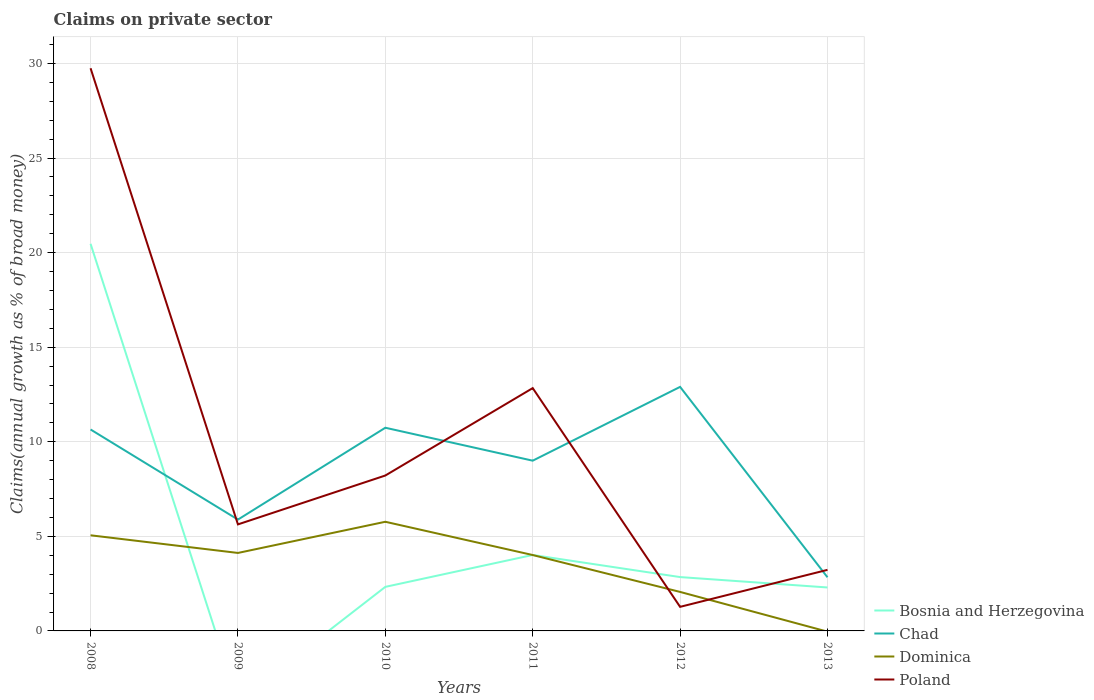How many different coloured lines are there?
Your response must be concise. 4. Does the line corresponding to Poland intersect with the line corresponding to Dominica?
Ensure brevity in your answer.  Yes. Is the number of lines equal to the number of legend labels?
Offer a very short reply. No. Across all years, what is the maximum percentage of broad money claimed on private sector in Dominica?
Keep it short and to the point. 0. What is the total percentage of broad money claimed on private sector in Chad in the graph?
Give a very brief answer. 10.07. What is the difference between the highest and the second highest percentage of broad money claimed on private sector in Poland?
Offer a very short reply. 28.48. What is the difference between the highest and the lowest percentage of broad money claimed on private sector in Chad?
Your answer should be very brief. 4. Is the percentage of broad money claimed on private sector in Bosnia and Herzegovina strictly greater than the percentage of broad money claimed on private sector in Dominica over the years?
Your response must be concise. No. How many years are there in the graph?
Your answer should be compact. 6. Are the values on the major ticks of Y-axis written in scientific E-notation?
Offer a very short reply. No. Does the graph contain any zero values?
Ensure brevity in your answer.  Yes. How many legend labels are there?
Give a very brief answer. 4. What is the title of the graph?
Keep it short and to the point. Claims on private sector. What is the label or title of the Y-axis?
Your answer should be very brief. Claims(annual growth as % of broad money). What is the Claims(annual growth as % of broad money) of Bosnia and Herzegovina in 2008?
Your answer should be compact. 20.47. What is the Claims(annual growth as % of broad money) in Chad in 2008?
Ensure brevity in your answer.  10.65. What is the Claims(annual growth as % of broad money) in Dominica in 2008?
Give a very brief answer. 5.06. What is the Claims(annual growth as % of broad money) in Poland in 2008?
Provide a succinct answer. 29.75. What is the Claims(annual growth as % of broad money) in Chad in 2009?
Provide a short and direct response. 5.89. What is the Claims(annual growth as % of broad money) of Dominica in 2009?
Provide a succinct answer. 4.12. What is the Claims(annual growth as % of broad money) of Poland in 2009?
Your answer should be very brief. 5.63. What is the Claims(annual growth as % of broad money) of Bosnia and Herzegovina in 2010?
Offer a terse response. 2.33. What is the Claims(annual growth as % of broad money) of Chad in 2010?
Offer a terse response. 10.74. What is the Claims(annual growth as % of broad money) of Dominica in 2010?
Your answer should be very brief. 5.77. What is the Claims(annual growth as % of broad money) of Poland in 2010?
Your response must be concise. 8.22. What is the Claims(annual growth as % of broad money) of Bosnia and Herzegovina in 2011?
Offer a terse response. 4.02. What is the Claims(annual growth as % of broad money) of Chad in 2011?
Offer a terse response. 9. What is the Claims(annual growth as % of broad money) of Dominica in 2011?
Give a very brief answer. 4.01. What is the Claims(annual growth as % of broad money) of Poland in 2011?
Provide a succinct answer. 12.84. What is the Claims(annual growth as % of broad money) of Bosnia and Herzegovina in 2012?
Offer a very short reply. 2.85. What is the Claims(annual growth as % of broad money) in Chad in 2012?
Your response must be concise. 12.9. What is the Claims(annual growth as % of broad money) in Dominica in 2012?
Give a very brief answer. 2.06. What is the Claims(annual growth as % of broad money) of Poland in 2012?
Provide a succinct answer. 1.27. What is the Claims(annual growth as % of broad money) of Bosnia and Herzegovina in 2013?
Make the answer very short. 2.3. What is the Claims(annual growth as % of broad money) of Chad in 2013?
Your answer should be compact. 2.84. What is the Claims(annual growth as % of broad money) of Dominica in 2013?
Your answer should be compact. 0. What is the Claims(annual growth as % of broad money) of Poland in 2013?
Give a very brief answer. 3.23. Across all years, what is the maximum Claims(annual growth as % of broad money) in Bosnia and Herzegovina?
Ensure brevity in your answer.  20.47. Across all years, what is the maximum Claims(annual growth as % of broad money) in Chad?
Give a very brief answer. 12.9. Across all years, what is the maximum Claims(annual growth as % of broad money) of Dominica?
Your answer should be compact. 5.77. Across all years, what is the maximum Claims(annual growth as % of broad money) in Poland?
Offer a very short reply. 29.75. Across all years, what is the minimum Claims(annual growth as % of broad money) in Bosnia and Herzegovina?
Offer a very short reply. 0. Across all years, what is the minimum Claims(annual growth as % of broad money) of Chad?
Ensure brevity in your answer.  2.84. Across all years, what is the minimum Claims(annual growth as % of broad money) in Dominica?
Provide a short and direct response. 0. Across all years, what is the minimum Claims(annual growth as % of broad money) in Poland?
Your response must be concise. 1.27. What is the total Claims(annual growth as % of broad money) in Bosnia and Herzegovina in the graph?
Provide a short and direct response. 31.96. What is the total Claims(annual growth as % of broad money) of Chad in the graph?
Keep it short and to the point. 52.02. What is the total Claims(annual growth as % of broad money) in Dominica in the graph?
Give a very brief answer. 21.02. What is the total Claims(annual growth as % of broad money) in Poland in the graph?
Your answer should be very brief. 60.94. What is the difference between the Claims(annual growth as % of broad money) in Chad in 2008 and that in 2009?
Make the answer very short. 4.76. What is the difference between the Claims(annual growth as % of broad money) in Dominica in 2008 and that in 2009?
Give a very brief answer. 0.93. What is the difference between the Claims(annual growth as % of broad money) of Poland in 2008 and that in 2009?
Offer a terse response. 24.12. What is the difference between the Claims(annual growth as % of broad money) in Bosnia and Herzegovina in 2008 and that in 2010?
Your answer should be very brief. 18.14. What is the difference between the Claims(annual growth as % of broad money) in Chad in 2008 and that in 2010?
Give a very brief answer. -0.09. What is the difference between the Claims(annual growth as % of broad money) of Dominica in 2008 and that in 2010?
Keep it short and to the point. -0.71. What is the difference between the Claims(annual growth as % of broad money) in Poland in 2008 and that in 2010?
Your answer should be very brief. 21.53. What is the difference between the Claims(annual growth as % of broad money) in Bosnia and Herzegovina in 2008 and that in 2011?
Give a very brief answer. 16.45. What is the difference between the Claims(annual growth as % of broad money) of Chad in 2008 and that in 2011?
Keep it short and to the point. 1.65. What is the difference between the Claims(annual growth as % of broad money) of Dominica in 2008 and that in 2011?
Give a very brief answer. 1.04. What is the difference between the Claims(annual growth as % of broad money) of Poland in 2008 and that in 2011?
Your answer should be compact. 16.91. What is the difference between the Claims(annual growth as % of broad money) in Bosnia and Herzegovina in 2008 and that in 2012?
Your answer should be compact. 17.62. What is the difference between the Claims(annual growth as % of broad money) of Chad in 2008 and that in 2012?
Provide a succinct answer. -2.25. What is the difference between the Claims(annual growth as % of broad money) of Dominica in 2008 and that in 2012?
Make the answer very short. 2.99. What is the difference between the Claims(annual growth as % of broad money) in Poland in 2008 and that in 2012?
Provide a short and direct response. 28.48. What is the difference between the Claims(annual growth as % of broad money) in Bosnia and Herzegovina in 2008 and that in 2013?
Ensure brevity in your answer.  18.17. What is the difference between the Claims(annual growth as % of broad money) of Chad in 2008 and that in 2013?
Your response must be concise. 7.81. What is the difference between the Claims(annual growth as % of broad money) of Poland in 2008 and that in 2013?
Give a very brief answer. 26.52. What is the difference between the Claims(annual growth as % of broad money) of Chad in 2009 and that in 2010?
Your response must be concise. -4.86. What is the difference between the Claims(annual growth as % of broad money) in Dominica in 2009 and that in 2010?
Keep it short and to the point. -1.65. What is the difference between the Claims(annual growth as % of broad money) in Poland in 2009 and that in 2010?
Your answer should be compact. -2.58. What is the difference between the Claims(annual growth as % of broad money) of Chad in 2009 and that in 2011?
Offer a very short reply. -3.12. What is the difference between the Claims(annual growth as % of broad money) in Dominica in 2009 and that in 2011?
Make the answer very short. 0.11. What is the difference between the Claims(annual growth as % of broad money) of Poland in 2009 and that in 2011?
Give a very brief answer. -7.21. What is the difference between the Claims(annual growth as % of broad money) in Chad in 2009 and that in 2012?
Keep it short and to the point. -7.02. What is the difference between the Claims(annual growth as % of broad money) in Dominica in 2009 and that in 2012?
Offer a very short reply. 2.06. What is the difference between the Claims(annual growth as % of broad money) in Poland in 2009 and that in 2012?
Make the answer very short. 4.36. What is the difference between the Claims(annual growth as % of broad money) in Chad in 2009 and that in 2013?
Give a very brief answer. 3.05. What is the difference between the Claims(annual growth as % of broad money) in Poland in 2009 and that in 2013?
Your answer should be very brief. 2.4. What is the difference between the Claims(annual growth as % of broad money) of Bosnia and Herzegovina in 2010 and that in 2011?
Give a very brief answer. -1.69. What is the difference between the Claims(annual growth as % of broad money) of Chad in 2010 and that in 2011?
Your response must be concise. 1.74. What is the difference between the Claims(annual growth as % of broad money) in Dominica in 2010 and that in 2011?
Make the answer very short. 1.76. What is the difference between the Claims(annual growth as % of broad money) of Poland in 2010 and that in 2011?
Provide a succinct answer. -4.62. What is the difference between the Claims(annual growth as % of broad money) in Bosnia and Herzegovina in 2010 and that in 2012?
Your answer should be compact. -0.52. What is the difference between the Claims(annual growth as % of broad money) of Chad in 2010 and that in 2012?
Your response must be concise. -2.16. What is the difference between the Claims(annual growth as % of broad money) in Dominica in 2010 and that in 2012?
Your response must be concise. 3.71. What is the difference between the Claims(annual growth as % of broad money) of Poland in 2010 and that in 2012?
Your answer should be very brief. 6.94. What is the difference between the Claims(annual growth as % of broad money) in Bosnia and Herzegovina in 2010 and that in 2013?
Make the answer very short. 0.03. What is the difference between the Claims(annual growth as % of broad money) of Chad in 2010 and that in 2013?
Your response must be concise. 7.91. What is the difference between the Claims(annual growth as % of broad money) in Poland in 2010 and that in 2013?
Your answer should be compact. 4.99. What is the difference between the Claims(annual growth as % of broad money) of Bosnia and Herzegovina in 2011 and that in 2012?
Your answer should be compact. 1.17. What is the difference between the Claims(annual growth as % of broad money) of Chad in 2011 and that in 2012?
Make the answer very short. -3.9. What is the difference between the Claims(annual growth as % of broad money) of Dominica in 2011 and that in 2012?
Your answer should be very brief. 1.95. What is the difference between the Claims(annual growth as % of broad money) of Poland in 2011 and that in 2012?
Give a very brief answer. 11.57. What is the difference between the Claims(annual growth as % of broad money) in Bosnia and Herzegovina in 2011 and that in 2013?
Ensure brevity in your answer.  1.72. What is the difference between the Claims(annual growth as % of broad money) in Chad in 2011 and that in 2013?
Your response must be concise. 6.17. What is the difference between the Claims(annual growth as % of broad money) of Poland in 2011 and that in 2013?
Ensure brevity in your answer.  9.61. What is the difference between the Claims(annual growth as % of broad money) of Bosnia and Herzegovina in 2012 and that in 2013?
Keep it short and to the point. 0.55. What is the difference between the Claims(annual growth as % of broad money) of Chad in 2012 and that in 2013?
Your answer should be very brief. 10.07. What is the difference between the Claims(annual growth as % of broad money) of Poland in 2012 and that in 2013?
Make the answer very short. -1.96. What is the difference between the Claims(annual growth as % of broad money) in Bosnia and Herzegovina in 2008 and the Claims(annual growth as % of broad money) in Chad in 2009?
Ensure brevity in your answer.  14.58. What is the difference between the Claims(annual growth as % of broad money) of Bosnia and Herzegovina in 2008 and the Claims(annual growth as % of broad money) of Dominica in 2009?
Your answer should be compact. 16.34. What is the difference between the Claims(annual growth as % of broad money) of Bosnia and Herzegovina in 2008 and the Claims(annual growth as % of broad money) of Poland in 2009?
Your answer should be very brief. 14.84. What is the difference between the Claims(annual growth as % of broad money) of Chad in 2008 and the Claims(annual growth as % of broad money) of Dominica in 2009?
Ensure brevity in your answer.  6.53. What is the difference between the Claims(annual growth as % of broad money) of Chad in 2008 and the Claims(annual growth as % of broad money) of Poland in 2009?
Offer a very short reply. 5.02. What is the difference between the Claims(annual growth as % of broad money) in Dominica in 2008 and the Claims(annual growth as % of broad money) in Poland in 2009?
Provide a succinct answer. -0.58. What is the difference between the Claims(annual growth as % of broad money) in Bosnia and Herzegovina in 2008 and the Claims(annual growth as % of broad money) in Chad in 2010?
Ensure brevity in your answer.  9.73. What is the difference between the Claims(annual growth as % of broad money) of Bosnia and Herzegovina in 2008 and the Claims(annual growth as % of broad money) of Dominica in 2010?
Offer a terse response. 14.7. What is the difference between the Claims(annual growth as % of broad money) of Bosnia and Herzegovina in 2008 and the Claims(annual growth as % of broad money) of Poland in 2010?
Your answer should be compact. 12.25. What is the difference between the Claims(annual growth as % of broad money) of Chad in 2008 and the Claims(annual growth as % of broad money) of Dominica in 2010?
Offer a very short reply. 4.88. What is the difference between the Claims(annual growth as % of broad money) of Chad in 2008 and the Claims(annual growth as % of broad money) of Poland in 2010?
Give a very brief answer. 2.43. What is the difference between the Claims(annual growth as % of broad money) of Dominica in 2008 and the Claims(annual growth as % of broad money) of Poland in 2010?
Provide a short and direct response. -3.16. What is the difference between the Claims(annual growth as % of broad money) in Bosnia and Herzegovina in 2008 and the Claims(annual growth as % of broad money) in Chad in 2011?
Ensure brevity in your answer.  11.47. What is the difference between the Claims(annual growth as % of broad money) of Bosnia and Herzegovina in 2008 and the Claims(annual growth as % of broad money) of Dominica in 2011?
Provide a short and direct response. 16.46. What is the difference between the Claims(annual growth as % of broad money) of Bosnia and Herzegovina in 2008 and the Claims(annual growth as % of broad money) of Poland in 2011?
Keep it short and to the point. 7.63. What is the difference between the Claims(annual growth as % of broad money) in Chad in 2008 and the Claims(annual growth as % of broad money) in Dominica in 2011?
Offer a terse response. 6.64. What is the difference between the Claims(annual growth as % of broad money) of Chad in 2008 and the Claims(annual growth as % of broad money) of Poland in 2011?
Your response must be concise. -2.19. What is the difference between the Claims(annual growth as % of broad money) in Dominica in 2008 and the Claims(annual growth as % of broad money) in Poland in 2011?
Offer a terse response. -7.78. What is the difference between the Claims(annual growth as % of broad money) of Bosnia and Herzegovina in 2008 and the Claims(annual growth as % of broad money) of Chad in 2012?
Offer a terse response. 7.57. What is the difference between the Claims(annual growth as % of broad money) of Bosnia and Herzegovina in 2008 and the Claims(annual growth as % of broad money) of Dominica in 2012?
Your response must be concise. 18.41. What is the difference between the Claims(annual growth as % of broad money) of Bosnia and Herzegovina in 2008 and the Claims(annual growth as % of broad money) of Poland in 2012?
Your answer should be very brief. 19.2. What is the difference between the Claims(annual growth as % of broad money) of Chad in 2008 and the Claims(annual growth as % of broad money) of Dominica in 2012?
Your response must be concise. 8.59. What is the difference between the Claims(annual growth as % of broad money) of Chad in 2008 and the Claims(annual growth as % of broad money) of Poland in 2012?
Ensure brevity in your answer.  9.38. What is the difference between the Claims(annual growth as % of broad money) in Dominica in 2008 and the Claims(annual growth as % of broad money) in Poland in 2012?
Make the answer very short. 3.78. What is the difference between the Claims(annual growth as % of broad money) of Bosnia and Herzegovina in 2008 and the Claims(annual growth as % of broad money) of Chad in 2013?
Your answer should be very brief. 17.63. What is the difference between the Claims(annual growth as % of broad money) in Bosnia and Herzegovina in 2008 and the Claims(annual growth as % of broad money) in Poland in 2013?
Your answer should be compact. 17.24. What is the difference between the Claims(annual growth as % of broad money) of Chad in 2008 and the Claims(annual growth as % of broad money) of Poland in 2013?
Your answer should be very brief. 7.42. What is the difference between the Claims(annual growth as % of broad money) in Dominica in 2008 and the Claims(annual growth as % of broad money) in Poland in 2013?
Your answer should be very brief. 1.83. What is the difference between the Claims(annual growth as % of broad money) of Chad in 2009 and the Claims(annual growth as % of broad money) of Dominica in 2010?
Your answer should be very brief. 0.12. What is the difference between the Claims(annual growth as % of broad money) in Chad in 2009 and the Claims(annual growth as % of broad money) in Poland in 2010?
Make the answer very short. -2.33. What is the difference between the Claims(annual growth as % of broad money) in Dominica in 2009 and the Claims(annual growth as % of broad money) in Poland in 2010?
Your answer should be very brief. -4.09. What is the difference between the Claims(annual growth as % of broad money) in Chad in 2009 and the Claims(annual growth as % of broad money) in Dominica in 2011?
Provide a succinct answer. 1.87. What is the difference between the Claims(annual growth as % of broad money) in Chad in 2009 and the Claims(annual growth as % of broad money) in Poland in 2011?
Give a very brief answer. -6.95. What is the difference between the Claims(annual growth as % of broad money) of Dominica in 2009 and the Claims(annual growth as % of broad money) of Poland in 2011?
Your response must be concise. -8.72. What is the difference between the Claims(annual growth as % of broad money) in Chad in 2009 and the Claims(annual growth as % of broad money) in Dominica in 2012?
Make the answer very short. 3.82. What is the difference between the Claims(annual growth as % of broad money) in Chad in 2009 and the Claims(annual growth as % of broad money) in Poland in 2012?
Your answer should be compact. 4.61. What is the difference between the Claims(annual growth as % of broad money) in Dominica in 2009 and the Claims(annual growth as % of broad money) in Poland in 2012?
Ensure brevity in your answer.  2.85. What is the difference between the Claims(annual growth as % of broad money) of Chad in 2009 and the Claims(annual growth as % of broad money) of Poland in 2013?
Your answer should be very brief. 2.66. What is the difference between the Claims(annual growth as % of broad money) of Dominica in 2009 and the Claims(annual growth as % of broad money) of Poland in 2013?
Offer a terse response. 0.89. What is the difference between the Claims(annual growth as % of broad money) of Bosnia and Herzegovina in 2010 and the Claims(annual growth as % of broad money) of Chad in 2011?
Ensure brevity in your answer.  -6.67. What is the difference between the Claims(annual growth as % of broad money) in Bosnia and Herzegovina in 2010 and the Claims(annual growth as % of broad money) in Dominica in 2011?
Your answer should be very brief. -1.68. What is the difference between the Claims(annual growth as % of broad money) in Bosnia and Herzegovina in 2010 and the Claims(annual growth as % of broad money) in Poland in 2011?
Offer a terse response. -10.51. What is the difference between the Claims(annual growth as % of broad money) of Chad in 2010 and the Claims(annual growth as % of broad money) of Dominica in 2011?
Make the answer very short. 6.73. What is the difference between the Claims(annual growth as % of broad money) of Chad in 2010 and the Claims(annual growth as % of broad money) of Poland in 2011?
Provide a succinct answer. -2.1. What is the difference between the Claims(annual growth as % of broad money) in Dominica in 2010 and the Claims(annual growth as % of broad money) in Poland in 2011?
Offer a very short reply. -7.07. What is the difference between the Claims(annual growth as % of broad money) in Bosnia and Herzegovina in 2010 and the Claims(annual growth as % of broad money) in Chad in 2012?
Provide a succinct answer. -10.57. What is the difference between the Claims(annual growth as % of broad money) in Bosnia and Herzegovina in 2010 and the Claims(annual growth as % of broad money) in Dominica in 2012?
Offer a terse response. 0.27. What is the difference between the Claims(annual growth as % of broad money) of Bosnia and Herzegovina in 2010 and the Claims(annual growth as % of broad money) of Poland in 2012?
Provide a succinct answer. 1.06. What is the difference between the Claims(annual growth as % of broad money) of Chad in 2010 and the Claims(annual growth as % of broad money) of Dominica in 2012?
Your answer should be very brief. 8.68. What is the difference between the Claims(annual growth as % of broad money) in Chad in 2010 and the Claims(annual growth as % of broad money) in Poland in 2012?
Your response must be concise. 9.47. What is the difference between the Claims(annual growth as % of broad money) of Dominica in 2010 and the Claims(annual growth as % of broad money) of Poland in 2012?
Offer a terse response. 4.5. What is the difference between the Claims(annual growth as % of broad money) in Bosnia and Herzegovina in 2010 and the Claims(annual growth as % of broad money) in Chad in 2013?
Make the answer very short. -0.51. What is the difference between the Claims(annual growth as % of broad money) of Bosnia and Herzegovina in 2010 and the Claims(annual growth as % of broad money) of Poland in 2013?
Ensure brevity in your answer.  -0.9. What is the difference between the Claims(annual growth as % of broad money) in Chad in 2010 and the Claims(annual growth as % of broad money) in Poland in 2013?
Your response must be concise. 7.51. What is the difference between the Claims(annual growth as % of broad money) in Dominica in 2010 and the Claims(annual growth as % of broad money) in Poland in 2013?
Your answer should be very brief. 2.54. What is the difference between the Claims(annual growth as % of broad money) in Bosnia and Herzegovina in 2011 and the Claims(annual growth as % of broad money) in Chad in 2012?
Your response must be concise. -8.89. What is the difference between the Claims(annual growth as % of broad money) in Bosnia and Herzegovina in 2011 and the Claims(annual growth as % of broad money) in Dominica in 2012?
Your answer should be very brief. 1.95. What is the difference between the Claims(annual growth as % of broad money) of Bosnia and Herzegovina in 2011 and the Claims(annual growth as % of broad money) of Poland in 2012?
Ensure brevity in your answer.  2.74. What is the difference between the Claims(annual growth as % of broad money) in Chad in 2011 and the Claims(annual growth as % of broad money) in Dominica in 2012?
Ensure brevity in your answer.  6.94. What is the difference between the Claims(annual growth as % of broad money) of Chad in 2011 and the Claims(annual growth as % of broad money) of Poland in 2012?
Offer a terse response. 7.73. What is the difference between the Claims(annual growth as % of broad money) of Dominica in 2011 and the Claims(annual growth as % of broad money) of Poland in 2012?
Give a very brief answer. 2.74. What is the difference between the Claims(annual growth as % of broad money) in Bosnia and Herzegovina in 2011 and the Claims(annual growth as % of broad money) in Chad in 2013?
Your answer should be compact. 1.18. What is the difference between the Claims(annual growth as % of broad money) of Bosnia and Herzegovina in 2011 and the Claims(annual growth as % of broad money) of Poland in 2013?
Make the answer very short. 0.79. What is the difference between the Claims(annual growth as % of broad money) of Chad in 2011 and the Claims(annual growth as % of broad money) of Poland in 2013?
Your response must be concise. 5.77. What is the difference between the Claims(annual growth as % of broad money) of Dominica in 2011 and the Claims(annual growth as % of broad money) of Poland in 2013?
Your response must be concise. 0.78. What is the difference between the Claims(annual growth as % of broad money) in Bosnia and Herzegovina in 2012 and the Claims(annual growth as % of broad money) in Chad in 2013?
Your response must be concise. 0.01. What is the difference between the Claims(annual growth as % of broad money) in Bosnia and Herzegovina in 2012 and the Claims(annual growth as % of broad money) in Poland in 2013?
Provide a short and direct response. -0.38. What is the difference between the Claims(annual growth as % of broad money) in Chad in 2012 and the Claims(annual growth as % of broad money) in Poland in 2013?
Keep it short and to the point. 9.67. What is the difference between the Claims(annual growth as % of broad money) of Dominica in 2012 and the Claims(annual growth as % of broad money) of Poland in 2013?
Offer a very short reply. -1.17. What is the average Claims(annual growth as % of broad money) of Bosnia and Herzegovina per year?
Your response must be concise. 5.33. What is the average Claims(annual growth as % of broad money) of Chad per year?
Your answer should be compact. 8.67. What is the average Claims(annual growth as % of broad money) in Dominica per year?
Ensure brevity in your answer.  3.5. What is the average Claims(annual growth as % of broad money) of Poland per year?
Keep it short and to the point. 10.16. In the year 2008, what is the difference between the Claims(annual growth as % of broad money) in Bosnia and Herzegovina and Claims(annual growth as % of broad money) in Chad?
Offer a terse response. 9.82. In the year 2008, what is the difference between the Claims(annual growth as % of broad money) in Bosnia and Herzegovina and Claims(annual growth as % of broad money) in Dominica?
Offer a terse response. 15.41. In the year 2008, what is the difference between the Claims(annual growth as % of broad money) in Bosnia and Herzegovina and Claims(annual growth as % of broad money) in Poland?
Your answer should be very brief. -9.28. In the year 2008, what is the difference between the Claims(annual growth as % of broad money) in Chad and Claims(annual growth as % of broad money) in Dominica?
Provide a short and direct response. 5.59. In the year 2008, what is the difference between the Claims(annual growth as % of broad money) of Chad and Claims(annual growth as % of broad money) of Poland?
Ensure brevity in your answer.  -19.1. In the year 2008, what is the difference between the Claims(annual growth as % of broad money) of Dominica and Claims(annual growth as % of broad money) of Poland?
Your answer should be very brief. -24.69. In the year 2009, what is the difference between the Claims(annual growth as % of broad money) in Chad and Claims(annual growth as % of broad money) in Dominica?
Provide a succinct answer. 1.76. In the year 2009, what is the difference between the Claims(annual growth as % of broad money) in Chad and Claims(annual growth as % of broad money) in Poland?
Your answer should be very brief. 0.25. In the year 2009, what is the difference between the Claims(annual growth as % of broad money) of Dominica and Claims(annual growth as % of broad money) of Poland?
Provide a succinct answer. -1.51. In the year 2010, what is the difference between the Claims(annual growth as % of broad money) in Bosnia and Herzegovina and Claims(annual growth as % of broad money) in Chad?
Make the answer very short. -8.41. In the year 2010, what is the difference between the Claims(annual growth as % of broad money) in Bosnia and Herzegovina and Claims(annual growth as % of broad money) in Dominica?
Provide a succinct answer. -3.44. In the year 2010, what is the difference between the Claims(annual growth as % of broad money) in Bosnia and Herzegovina and Claims(annual growth as % of broad money) in Poland?
Make the answer very short. -5.89. In the year 2010, what is the difference between the Claims(annual growth as % of broad money) in Chad and Claims(annual growth as % of broad money) in Dominica?
Offer a very short reply. 4.97. In the year 2010, what is the difference between the Claims(annual growth as % of broad money) in Chad and Claims(annual growth as % of broad money) in Poland?
Ensure brevity in your answer.  2.53. In the year 2010, what is the difference between the Claims(annual growth as % of broad money) in Dominica and Claims(annual growth as % of broad money) in Poland?
Provide a short and direct response. -2.45. In the year 2011, what is the difference between the Claims(annual growth as % of broad money) in Bosnia and Herzegovina and Claims(annual growth as % of broad money) in Chad?
Offer a very short reply. -4.99. In the year 2011, what is the difference between the Claims(annual growth as % of broad money) of Bosnia and Herzegovina and Claims(annual growth as % of broad money) of Dominica?
Your response must be concise. 0. In the year 2011, what is the difference between the Claims(annual growth as % of broad money) of Bosnia and Herzegovina and Claims(annual growth as % of broad money) of Poland?
Make the answer very short. -8.82. In the year 2011, what is the difference between the Claims(annual growth as % of broad money) of Chad and Claims(annual growth as % of broad money) of Dominica?
Your response must be concise. 4.99. In the year 2011, what is the difference between the Claims(annual growth as % of broad money) of Chad and Claims(annual growth as % of broad money) of Poland?
Make the answer very short. -3.84. In the year 2011, what is the difference between the Claims(annual growth as % of broad money) of Dominica and Claims(annual growth as % of broad money) of Poland?
Provide a short and direct response. -8.83. In the year 2012, what is the difference between the Claims(annual growth as % of broad money) in Bosnia and Herzegovina and Claims(annual growth as % of broad money) in Chad?
Keep it short and to the point. -10.06. In the year 2012, what is the difference between the Claims(annual growth as % of broad money) in Bosnia and Herzegovina and Claims(annual growth as % of broad money) in Dominica?
Offer a very short reply. 0.79. In the year 2012, what is the difference between the Claims(annual growth as % of broad money) of Bosnia and Herzegovina and Claims(annual growth as % of broad money) of Poland?
Your response must be concise. 1.57. In the year 2012, what is the difference between the Claims(annual growth as % of broad money) of Chad and Claims(annual growth as % of broad money) of Dominica?
Offer a terse response. 10.84. In the year 2012, what is the difference between the Claims(annual growth as % of broad money) in Chad and Claims(annual growth as % of broad money) in Poland?
Your answer should be compact. 11.63. In the year 2012, what is the difference between the Claims(annual growth as % of broad money) of Dominica and Claims(annual growth as % of broad money) of Poland?
Offer a very short reply. 0.79. In the year 2013, what is the difference between the Claims(annual growth as % of broad money) of Bosnia and Herzegovina and Claims(annual growth as % of broad money) of Chad?
Keep it short and to the point. -0.54. In the year 2013, what is the difference between the Claims(annual growth as % of broad money) of Bosnia and Herzegovina and Claims(annual growth as % of broad money) of Poland?
Your answer should be very brief. -0.93. In the year 2013, what is the difference between the Claims(annual growth as % of broad money) in Chad and Claims(annual growth as % of broad money) in Poland?
Give a very brief answer. -0.39. What is the ratio of the Claims(annual growth as % of broad money) of Chad in 2008 to that in 2009?
Your answer should be compact. 1.81. What is the ratio of the Claims(annual growth as % of broad money) of Dominica in 2008 to that in 2009?
Your answer should be compact. 1.23. What is the ratio of the Claims(annual growth as % of broad money) of Poland in 2008 to that in 2009?
Keep it short and to the point. 5.28. What is the ratio of the Claims(annual growth as % of broad money) of Bosnia and Herzegovina in 2008 to that in 2010?
Ensure brevity in your answer.  8.79. What is the ratio of the Claims(annual growth as % of broad money) of Chad in 2008 to that in 2010?
Give a very brief answer. 0.99. What is the ratio of the Claims(annual growth as % of broad money) in Dominica in 2008 to that in 2010?
Your answer should be very brief. 0.88. What is the ratio of the Claims(annual growth as % of broad money) in Poland in 2008 to that in 2010?
Make the answer very short. 3.62. What is the ratio of the Claims(annual growth as % of broad money) of Bosnia and Herzegovina in 2008 to that in 2011?
Your answer should be compact. 5.1. What is the ratio of the Claims(annual growth as % of broad money) in Chad in 2008 to that in 2011?
Offer a very short reply. 1.18. What is the ratio of the Claims(annual growth as % of broad money) of Dominica in 2008 to that in 2011?
Keep it short and to the point. 1.26. What is the ratio of the Claims(annual growth as % of broad money) of Poland in 2008 to that in 2011?
Give a very brief answer. 2.32. What is the ratio of the Claims(annual growth as % of broad money) of Bosnia and Herzegovina in 2008 to that in 2012?
Offer a terse response. 7.19. What is the ratio of the Claims(annual growth as % of broad money) of Chad in 2008 to that in 2012?
Your answer should be very brief. 0.83. What is the ratio of the Claims(annual growth as % of broad money) of Dominica in 2008 to that in 2012?
Provide a succinct answer. 2.45. What is the ratio of the Claims(annual growth as % of broad money) in Poland in 2008 to that in 2012?
Offer a terse response. 23.37. What is the ratio of the Claims(annual growth as % of broad money) of Bosnia and Herzegovina in 2008 to that in 2013?
Offer a very short reply. 8.91. What is the ratio of the Claims(annual growth as % of broad money) in Chad in 2008 to that in 2013?
Your answer should be very brief. 3.76. What is the ratio of the Claims(annual growth as % of broad money) in Poland in 2008 to that in 2013?
Provide a short and direct response. 9.22. What is the ratio of the Claims(annual growth as % of broad money) in Chad in 2009 to that in 2010?
Keep it short and to the point. 0.55. What is the ratio of the Claims(annual growth as % of broad money) of Dominica in 2009 to that in 2010?
Your answer should be compact. 0.71. What is the ratio of the Claims(annual growth as % of broad money) in Poland in 2009 to that in 2010?
Provide a succinct answer. 0.69. What is the ratio of the Claims(annual growth as % of broad money) of Chad in 2009 to that in 2011?
Give a very brief answer. 0.65. What is the ratio of the Claims(annual growth as % of broad money) in Dominica in 2009 to that in 2011?
Offer a very short reply. 1.03. What is the ratio of the Claims(annual growth as % of broad money) in Poland in 2009 to that in 2011?
Provide a succinct answer. 0.44. What is the ratio of the Claims(annual growth as % of broad money) in Chad in 2009 to that in 2012?
Ensure brevity in your answer.  0.46. What is the ratio of the Claims(annual growth as % of broad money) of Dominica in 2009 to that in 2012?
Offer a terse response. 2. What is the ratio of the Claims(annual growth as % of broad money) of Poland in 2009 to that in 2012?
Keep it short and to the point. 4.42. What is the ratio of the Claims(annual growth as % of broad money) in Chad in 2009 to that in 2013?
Your response must be concise. 2.08. What is the ratio of the Claims(annual growth as % of broad money) in Poland in 2009 to that in 2013?
Make the answer very short. 1.74. What is the ratio of the Claims(annual growth as % of broad money) in Bosnia and Herzegovina in 2010 to that in 2011?
Provide a succinct answer. 0.58. What is the ratio of the Claims(annual growth as % of broad money) of Chad in 2010 to that in 2011?
Give a very brief answer. 1.19. What is the ratio of the Claims(annual growth as % of broad money) in Dominica in 2010 to that in 2011?
Your answer should be very brief. 1.44. What is the ratio of the Claims(annual growth as % of broad money) in Poland in 2010 to that in 2011?
Your answer should be compact. 0.64. What is the ratio of the Claims(annual growth as % of broad money) of Bosnia and Herzegovina in 2010 to that in 2012?
Offer a very short reply. 0.82. What is the ratio of the Claims(annual growth as % of broad money) in Chad in 2010 to that in 2012?
Offer a terse response. 0.83. What is the ratio of the Claims(annual growth as % of broad money) of Dominica in 2010 to that in 2012?
Make the answer very short. 2.8. What is the ratio of the Claims(annual growth as % of broad money) in Poland in 2010 to that in 2012?
Your answer should be very brief. 6.45. What is the ratio of the Claims(annual growth as % of broad money) of Bosnia and Herzegovina in 2010 to that in 2013?
Ensure brevity in your answer.  1.01. What is the ratio of the Claims(annual growth as % of broad money) of Chad in 2010 to that in 2013?
Your answer should be very brief. 3.79. What is the ratio of the Claims(annual growth as % of broad money) in Poland in 2010 to that in 2013?
Your response must be concise. 2.55. What is the ratio of the Claims(annual growth as % of broad money) in Bosnia and Herzegovina in 2011 to that in 2012?
Your answer should be compact. 1.41. What is the ratio of the Claims(annual growth as % of broad money) of Chad in 2011 to that in 2012?
Provide a succinct answer. 0.7. What is the ratio of the Claims(annual growth as % of broad money) in Dominica in 2011 to that in 2012?
Provide a succinct answer. 1.95. What is the ratio of the Claims(annual growth as % of broad money) in Poland in 2011 to that in 2012?
Ensure brevity in your answer.  10.08. What is the ratio of the Claims(annual growth as % of broad money) of Bosnia and Herzegovina in 2011 to that in 2013?
Offer a terse response. 1.75. What is the ratio of the Claims(annual growth as % of broad money) of Chad in 2011 to that in 2013?
Give a very brief answer. 3.17. What is the ratio of the Claims(annual growth as % of broad money) in Poland in 2011 to that in 2013?
Provide a short and direct response. 3.98. What is the ratio of the Claims(annual growth as % of broad money) in Bosnia and Herzegovina in 2012 to that in 2013?
Offer a very short reply. 1.24. What is the ratio of the Claims(annual growth as % of broad money) in Chad in 2012 to that in 2013?
Your response must be concise. 4.55. What is the ratio of the Claims(annual growth as % of broad money) in Poland in 2012 to that in 2013?
Your answer should be very brief. 0.39. What is the difference between the highest and the second highest Claims(annual growth as % of broad money) of Bosnia and Herzegovina?
Offer a very short reply. 16.45. What is the difference between the highest and the second highest Claims(annual growth as % of broad money) of Chad?
Your response must be concise. 2.16. What is the difference between the highest and the second highest Claims(annual growth as % of broad money) in Dominica?
Your answer should be very brief. 0.71. What is the difference between the highest and the second highest Claims(annual growth as % of broad money) in Poland?
Your answer should be compact. 16.91. What is the difference between the highest and the lowest Claims(annual growth as % of broad money) in Bosnia and Herzegovina?
Give a very brief answer. 20.47. What is the difference between the highest and the lowest Claims(annual growth as % of broad money) in Chad?
Provide a short and direct response. 10.07. What is the difference between the highest and the lowest Claims(annual growth as % of broad money) of Dominica?
Your response must be concise. 5.77. What is the difference between the highest and the lowest Claims(annual growth as % of broad money) of Poland?
Ensure brevity in your answer.  28.48. 